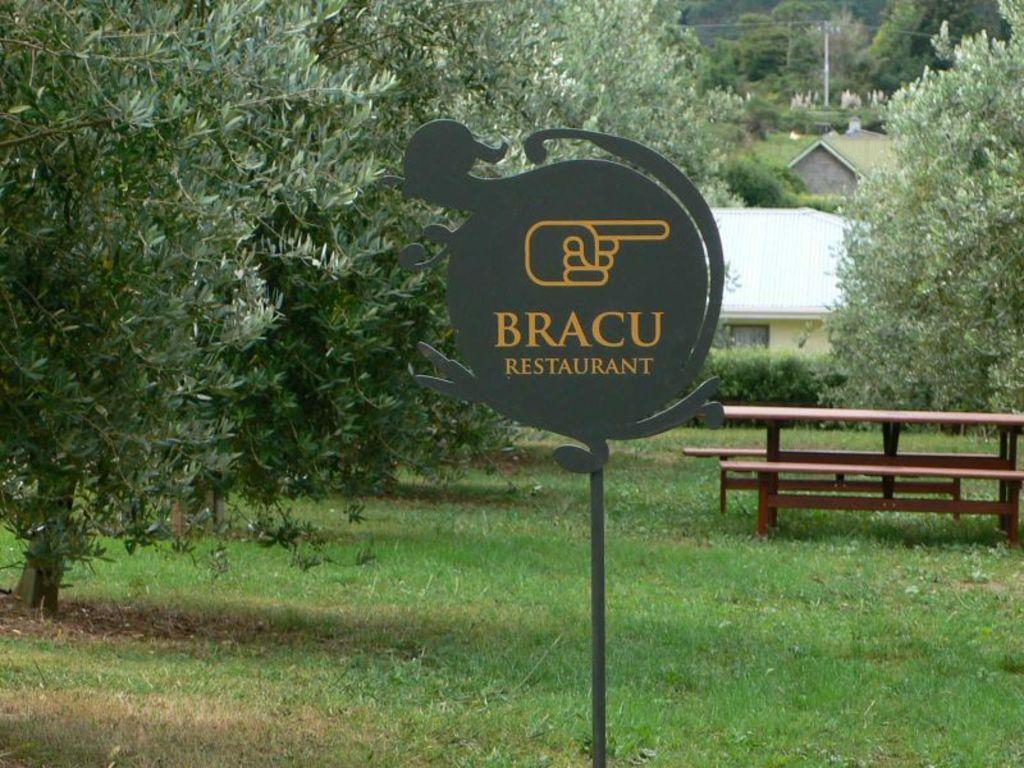What is attached to a pole in the image? There is a board attached to a pole in the image. What can be seen on the grass in the image? There is a picnic table on the grass in the image. What is visible in the background of the image? Houses and trees are present in the background of the image. Can you describe the pole in the image? There is a pole in the background of the image. How many circles can be seen on the picnic table in the image? There are no circles visible on the picnic table in the image. What type of pies are being served on the picnic table in the image? There are no pies present on the picnic table in the image. 